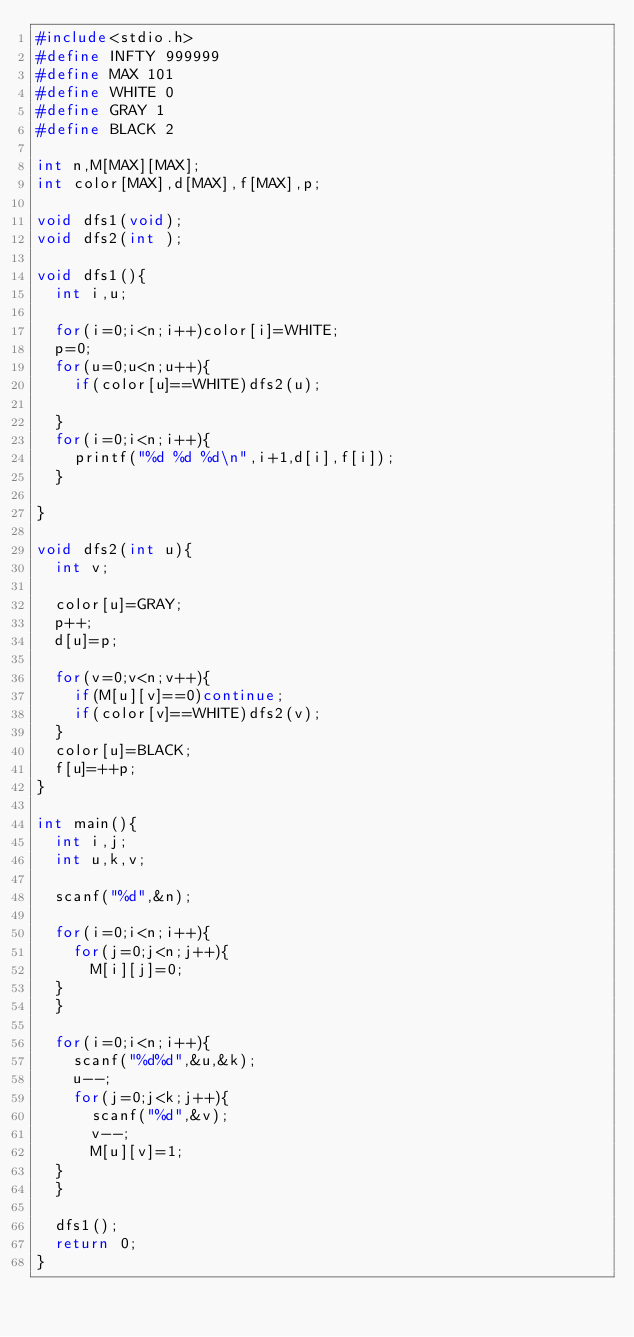Convert code to text. <code><loc_0><loc_0><loc_500><loc_500><_C_>#include<stdio.h>
#define INFTY 999999
#define MAX 101
#define WHITE 0
#define GRAY 1
#define BLACK 2

int n,M[MAX][MAX];
int color[MAX],d[MAX],f[MAX],p;

void dfs1(void);
void dfs2(int );

void dfs1(){
  int i,u;
  
  for(i=0;i<n;i++)color[i]=WHITE;
  p=0;
  for(u=0;u<n;u++){
    if(color[u]==WHITE)dfs2(u);

  }
  for(i=0;i<n;i++){
    printf("%d %d %d\n",i+1,d[i],f[i]);
  }
  
}

void dfs2(int u){
  int v;

  color[u]=GRAY;
  p++;
  d[u]=p;

  for(v=0;v<n;v++){
    if(M[u][v]==0)continue;
    if(color[v]==WHITE)dfs2(v);
  }
  color[u]=BLACK;
  f[u]=++p;
}

int main(){
  int i,j;
  int u,k,v;

  scanf("%d",&n);

  for(i=0;i<n;i++){
    for(j=0;j<n;j++){
      M[i][j]=0;
	}
  }

  for(i=0;i<n;i++){
    scanf("%d%d",&u,&k);
    u--;
    for(j=0;j<k;j++){
      scanf("%d",&v);
      v--;
      M[u][v]=1;
	}
  }

  dfs1();
  return 0;
}

</code> 